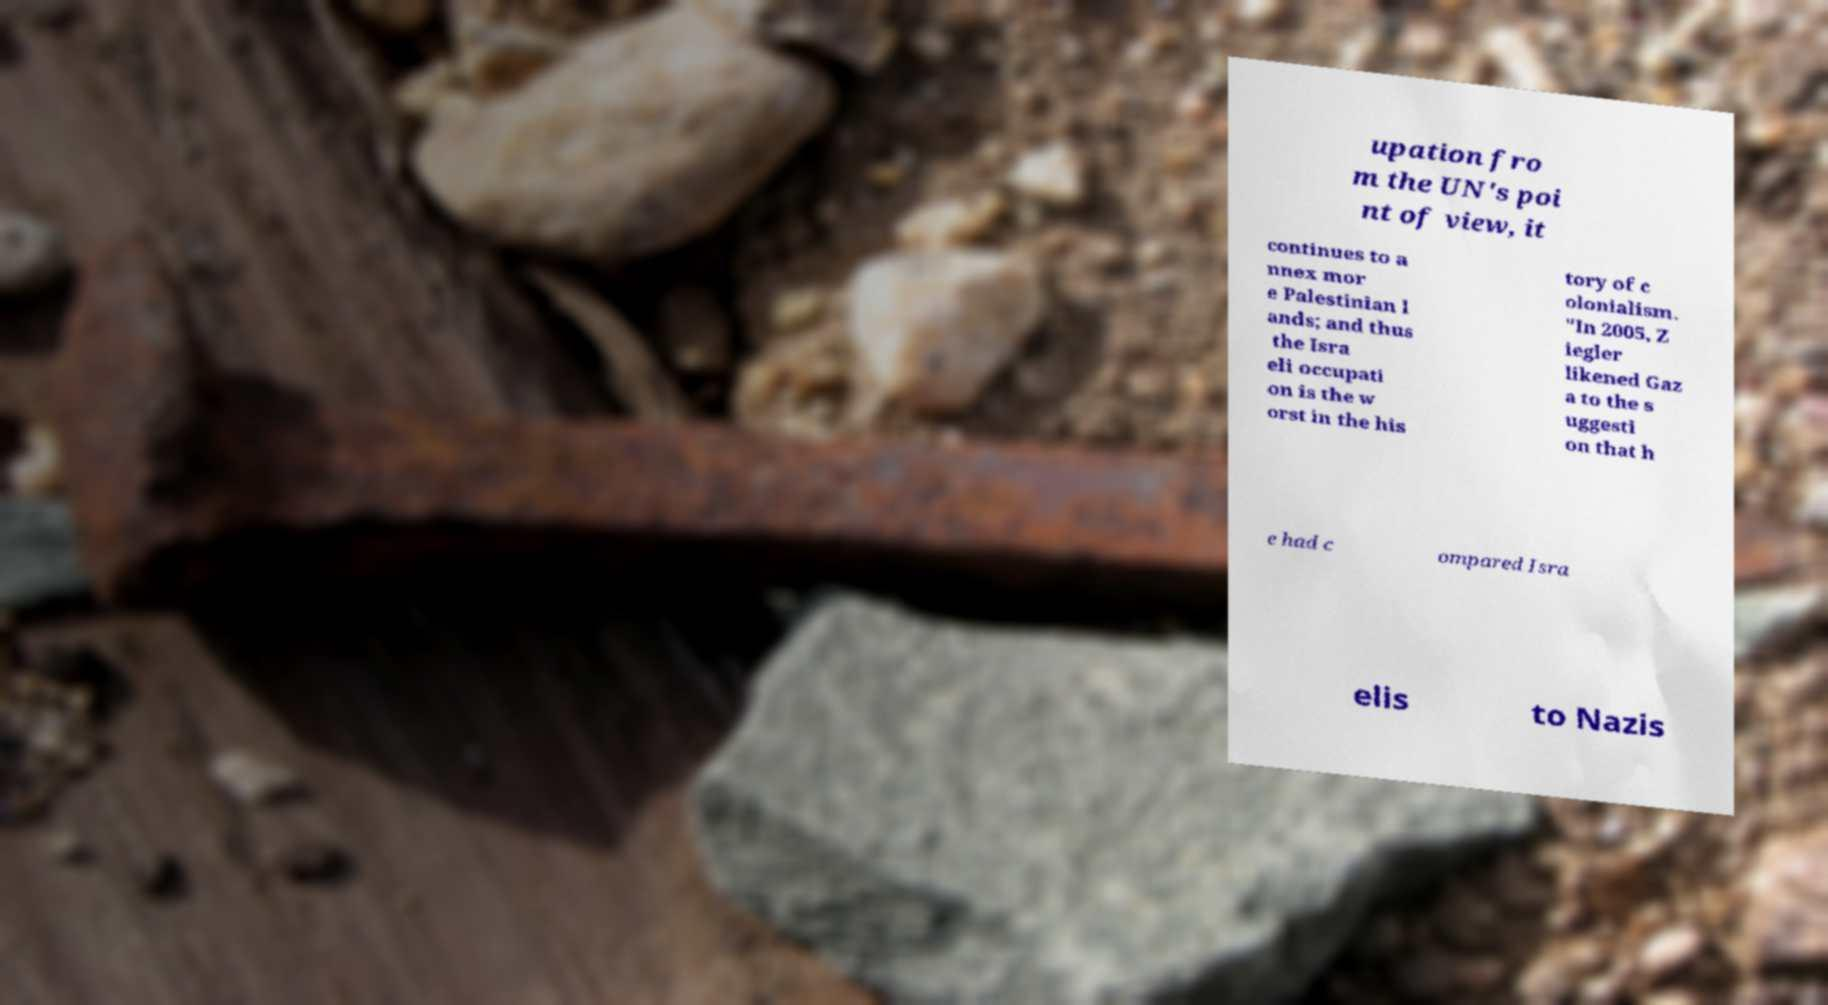Could you extract and type out the text from this image? upation fro m the UN's poi nt of view, it continues to a nnex mor e Palestinian l ands; and thus the Isra eli occupati on is the w orst in the his tory of c olonialism. "In 2005, Z iegler likened Gaz a to the s uggesti on that h e had c ompared Isra elis to Nazis 